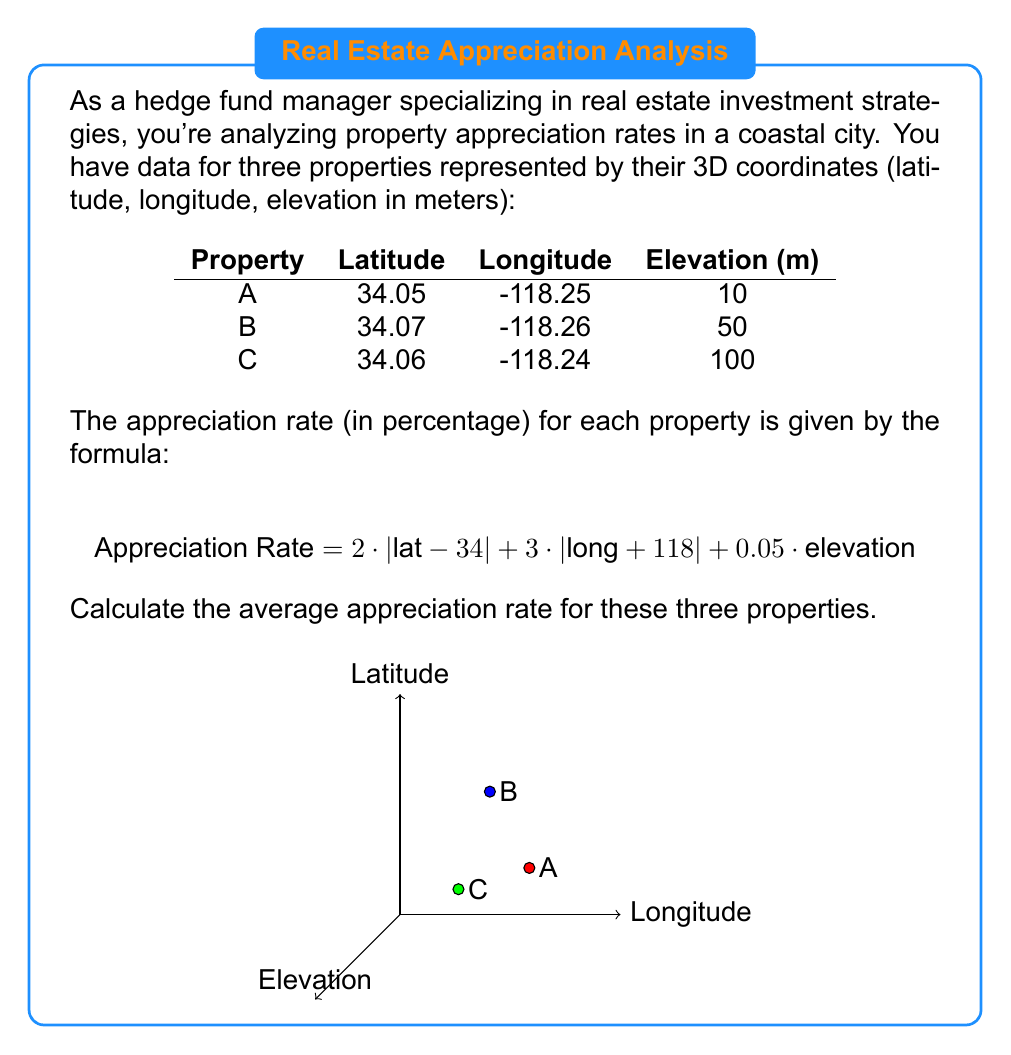Help me with this question. Let's solve this problem step by step:

1) First, we need to calculate the appreciation rate for each property using the given formula.

2) For Property A (34.05, -118.25, 10):
   $$ \begin{align*}
   \text{Rate}_A &= 2 \cdot |34.05 - 34| + 3 \cdot |-118.25 + 118| + 0.05 \cdot 10 \\
   &= 2 \cdot 0.05 + 3 \cdot 0.25 + 0.05 \cdot 10 \\
   &= 0.1 + 0.75 + 0.5 \\
   &= 1.35\%
   \end{align*} $$

3) For Property B (34.07, -118.26, 50):
   $$ \begin{align*}
   \text{Rate}_B &= 2 \cdot |34.07 - 34| + 3 \cdot |-118.26 + 118| + 0.05 \cdot 50 \\
   &= 2 \cdot 0.07 + 3 \cdot 0.26 + 0.05 \cdot 50 \\
   &= 0.14 + 0.78 + 2.5 \\
   &= 3.42\%
   \end{align*} $$

4) For Property C (34.06, -118.24, 100):
   $$ \begin{align*}
   \text{Rate}_C &= 2 \cdot |34.06 - 34| + 3 \cdot |-118.24 + 118| + 0.05 \cdot 100 \\
   &= 2 \cdot 0.06 + 3 \cdot 0.24 + 0.05 \cdot 100 \\
   &= 0.12 + 0.72 + 5 \\
   &= 5.84\%
   \end{align*} $$

5) Now, we calculate the average of these three rates:
   $$ \text{Average Rate} = \frac{\text{Rate}_A + \text{Rate}_B + \text{Rate}_C}{3} = \frac{1.35 + 3.42 + 5.84}{3} = \frac{10.61}{3} = 3.54\% $$

Therefore, the average appreciation rate for these three properties is 3.54%.
Answer: 3.54% 